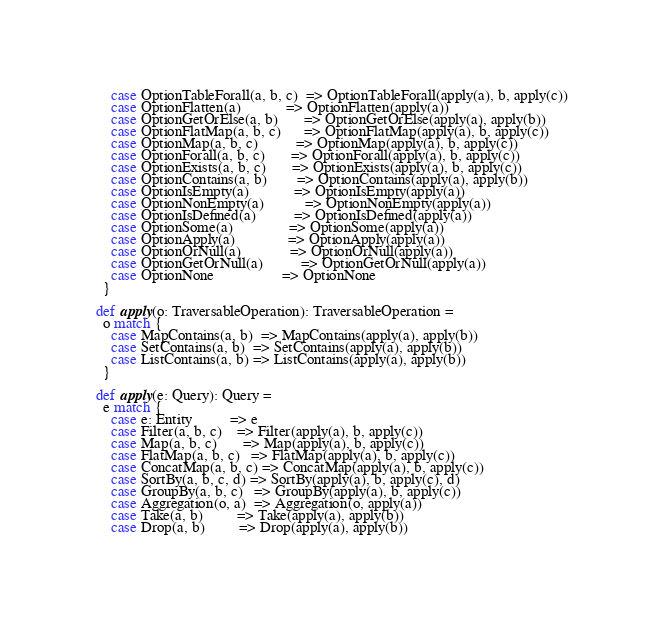<code> <loc_0><loc_0><loc_500><loc_500><_Scala_>      case OptionTableForall(a, b, c)  => OptionTableForall(apply(a), b, apply(c))
      case OptionFlatten(a)            => OptionFlatten(apply(a))
      case OptionGetOrElse(a, b)       => OptionGetOrElse(apply(a), apply(b))
      case OptionFlatMap(a, b, c)      => OptionFlatMap(apply(a), b, apply(c))
      case OptionMap(a, b, c)          => OptionMap(apply(a), b, apply(c))
      case OptionForall(a, b, c)       => OptionForall(apply(a), b, apply(c))
      case OptionExists(a, b, c)       => OptionExists(apply(a), b, apply(c))
      case OptionContains(a, b)        => OptionContains(apply(a), apply(b))
      case OptionIsEmpty(a)            => OptionIsEmpty(apply(a))
      case OptionNonEmpty(a)           => OptionNonEmpty(apply(a))
      case OptionIsDefined(a)          => OptionIsDefined(apply(a))
      case OptionSome(a)               => OptionSome(apply(a))
      case OptionApply(a)              => OptionApply(apply(a))
      case OptionOrNull(a)             => OptionOrNull(apply(a))
      case OptionGetOrNull(a)          => OptionGetOrNull(apply(a))
      case OptionNone                  => OptionNone
    }

  def apply(o: TraversableOperation): TraversableOperation =
    o match {
      case MapContains(a, b)  => MapContains(apply(a), apply(b))
      case SetContains(a, b)  => SetContains(apply(a), apply(b))
      case ListContains(a, b) => ListContains(apply(a), apply(b))
    }

  def apply(e: Query): Query =
    e match {
      case e: Entity          => e
      case Filter(a, b, c)    => Filter(apply(a), b, apply(c))
      case Map(a, b, c)       => Map(apply(a), b, apply(c))
      case FlatMap(a, b, c)   => FlatMap(apply(a), b, apply(c))
      case ConcatMap(a, b, c) => ConcatMap(apply(a), b, apply(c))
      case SortBy(a, b, c, d) => SortBy(apply(a), b, apply(c), d)
      case GroupBy(a, b, c)   => GroupBy(apply(a), b, apply(c))
      case Aggregation(o, a)  => Aggregation(o, apply(a))
      case Take(a, b)         => Take(apply(a), apply(b))
      case Drop(a, b)         => Drop(apply(a), apply(b))</code> 